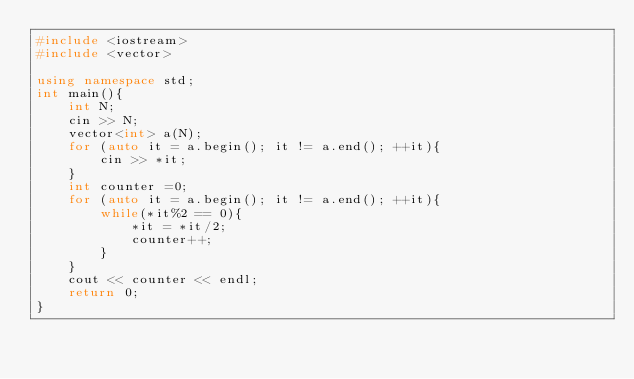Convert code to text. <code><loc_0><loc_0><loc_500><loc_500><_C++_>#include <iostream>
#include <vector>

using namespace std;
int main(){
    int N;
    cin >> N;
    vector<int> a(N);
    for (auto it = a.begin(); it != a.end(); ++it){
        cin >> *it;
    }
    int counter =0;
    for (auto it = a.begin(); it != a.end(); ++it){
        while(*it%2 == 0){
            *it = *it/2;
            counter++;
        }
    }
    cout << counter << endl;
    return 0;
}</code> 